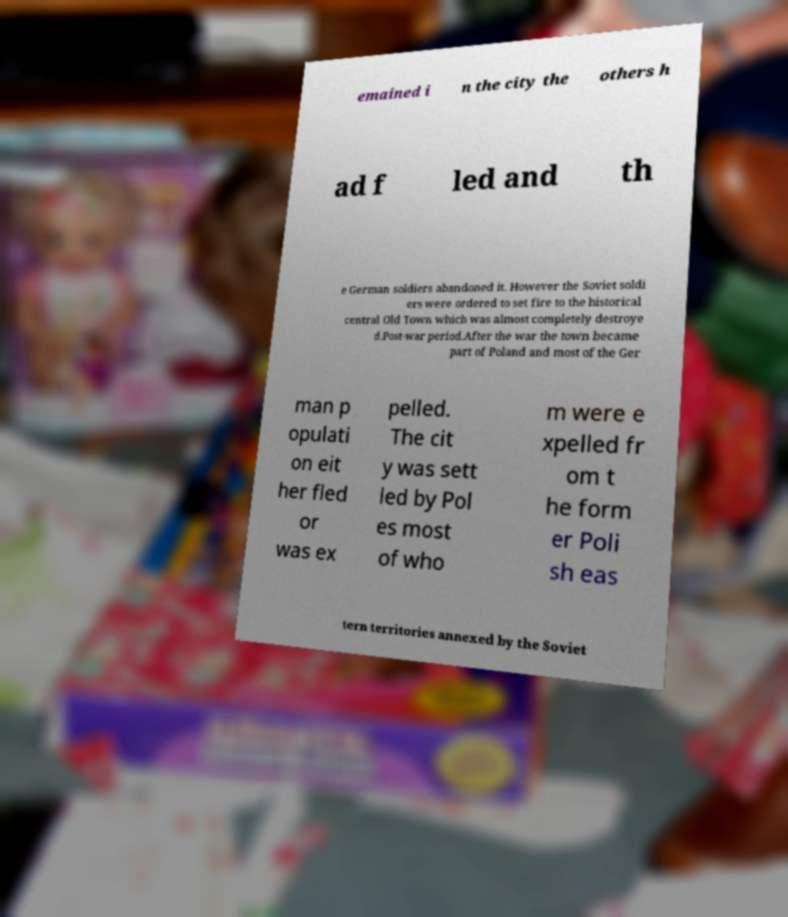Can you read and provide the text displayed in the image?This photo seems to have some interesting text. Can you extract and type it out for me? emained i n the city the others h ad f led and th e German soldiers abandoned it. However the Soviet soldi ers were ordered to set fire to the historical central Old Town which was almost completely destroye d.Post-war period.After the war the town became part of Poland and most of the Ger man p opulati on eit her fled or was ex pelled. The cit y was sett led by Pol es most of who m were e xpelled fr om t he form er Poli sh eas tern territories annexed by the Soviet 